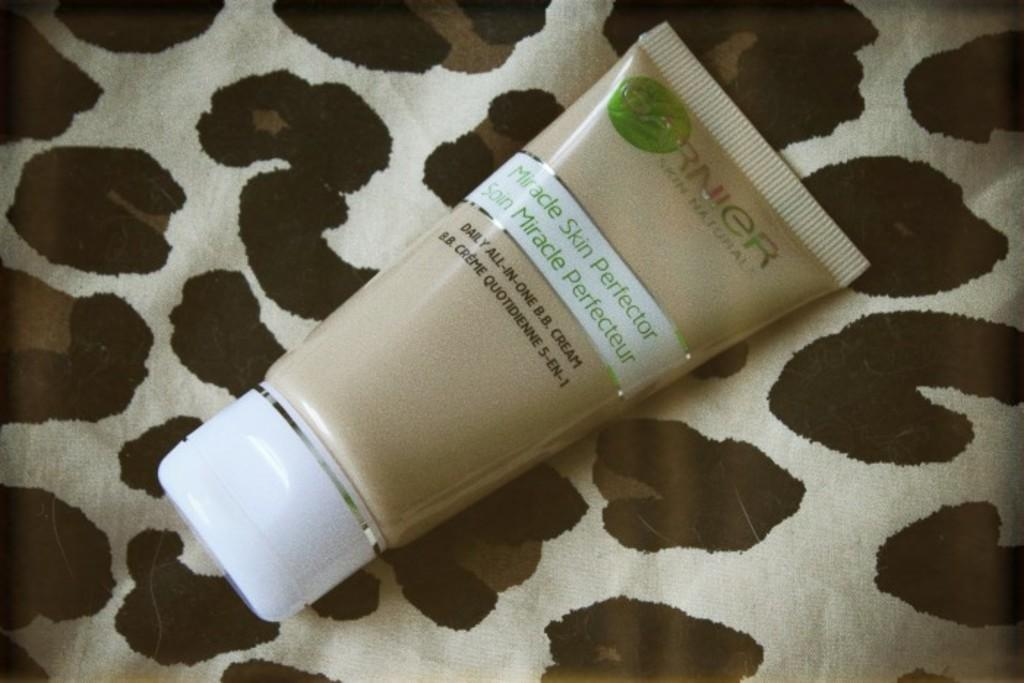<image>
Render a clear and concise summary of the photo. A skin protector cream sits on a table. 